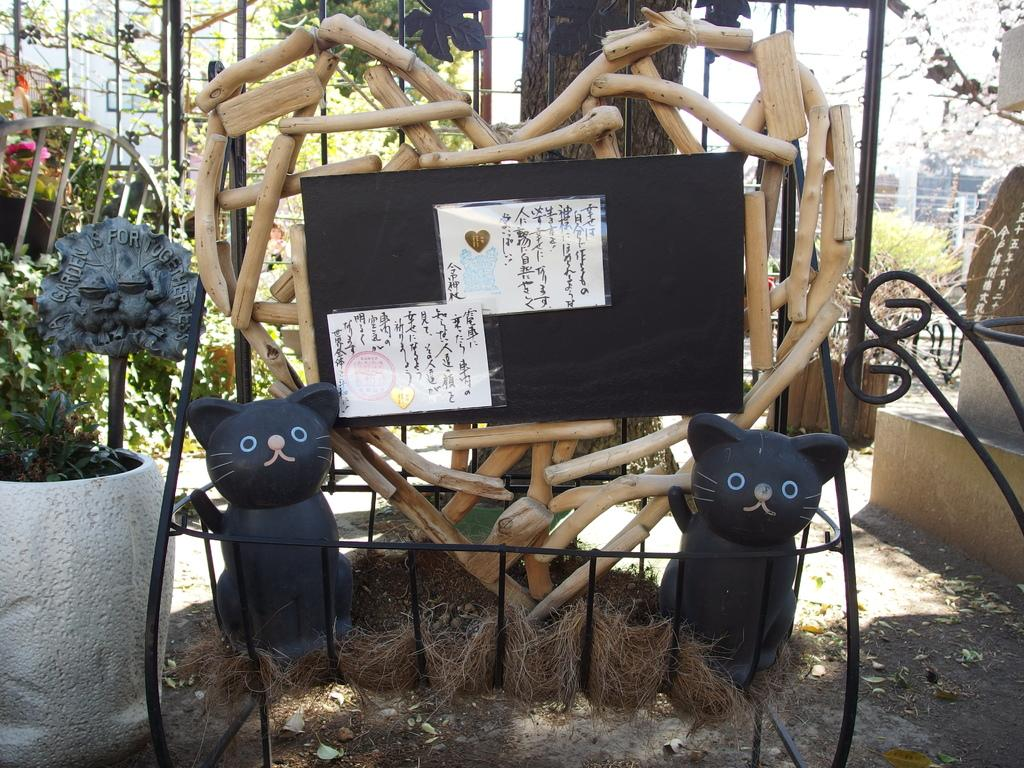What is present on the ground in the image? There are objects on the ground in the image. What type of vegetation can be seen in the image? There are plants and trees in the image. What type of structures are visible in the image? There are buildings in the image. Are there any architectural features in the image? Yes, there are stairs in the image. What tools are present in the image? There are drills in the image. Can you describe an object with text in the image? There is a poster with a label in the image. Can you describe an object with an image in the image? Yes, there is an object with an image in the image. How many chickens are visible in the image? There are no chickens present in the image. What type of knot is used to secure the drills in the image? There is no knot present in the image, as the drills are not tied or secured in any way. 